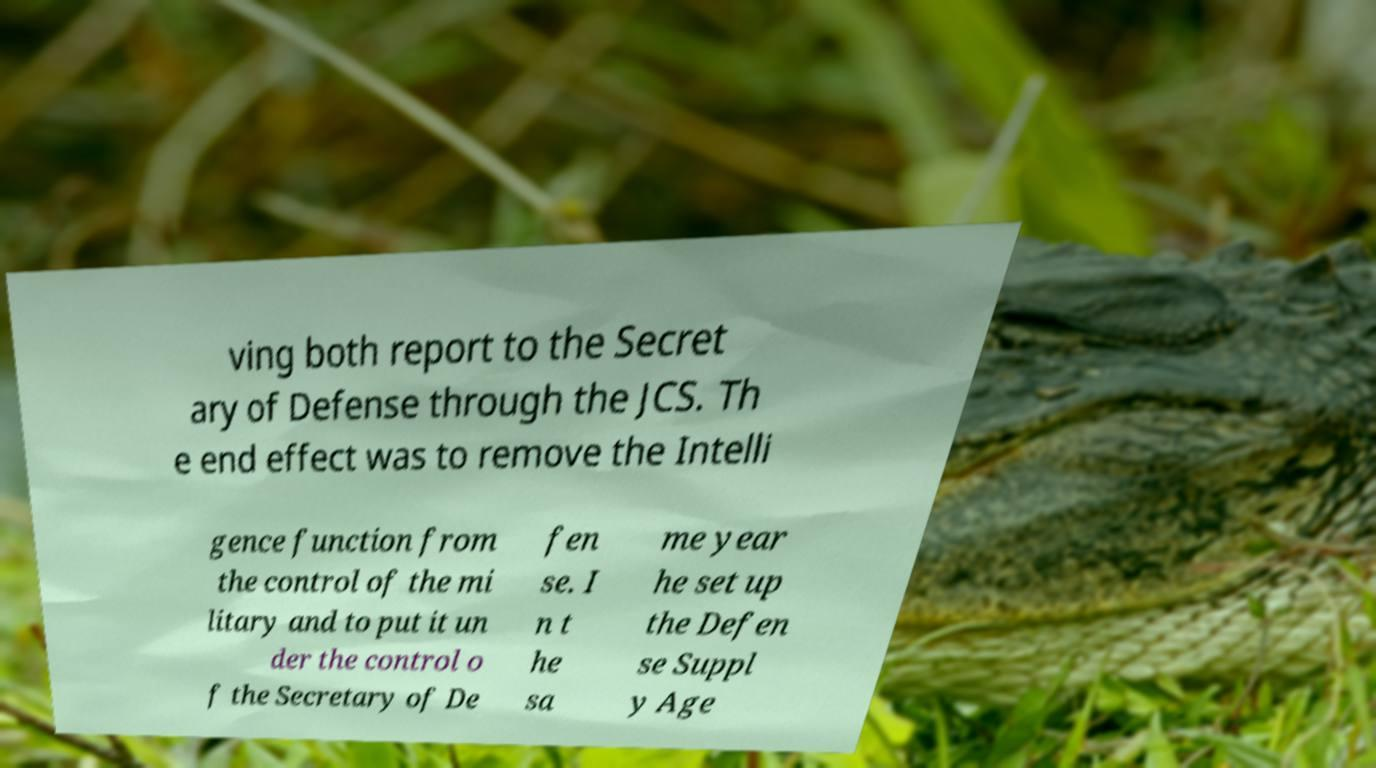What messages or text are displayed in this image? I need them in a readable, typed format. ving both report to the Secret ary of Defense through the JCS. Th e end effect was to remove the Intelli gence function from the control of the mi litary and to put it un der the control o f the Secretary of De fen se. I n t he sa me year he set up the Defen se Suppl y Age 